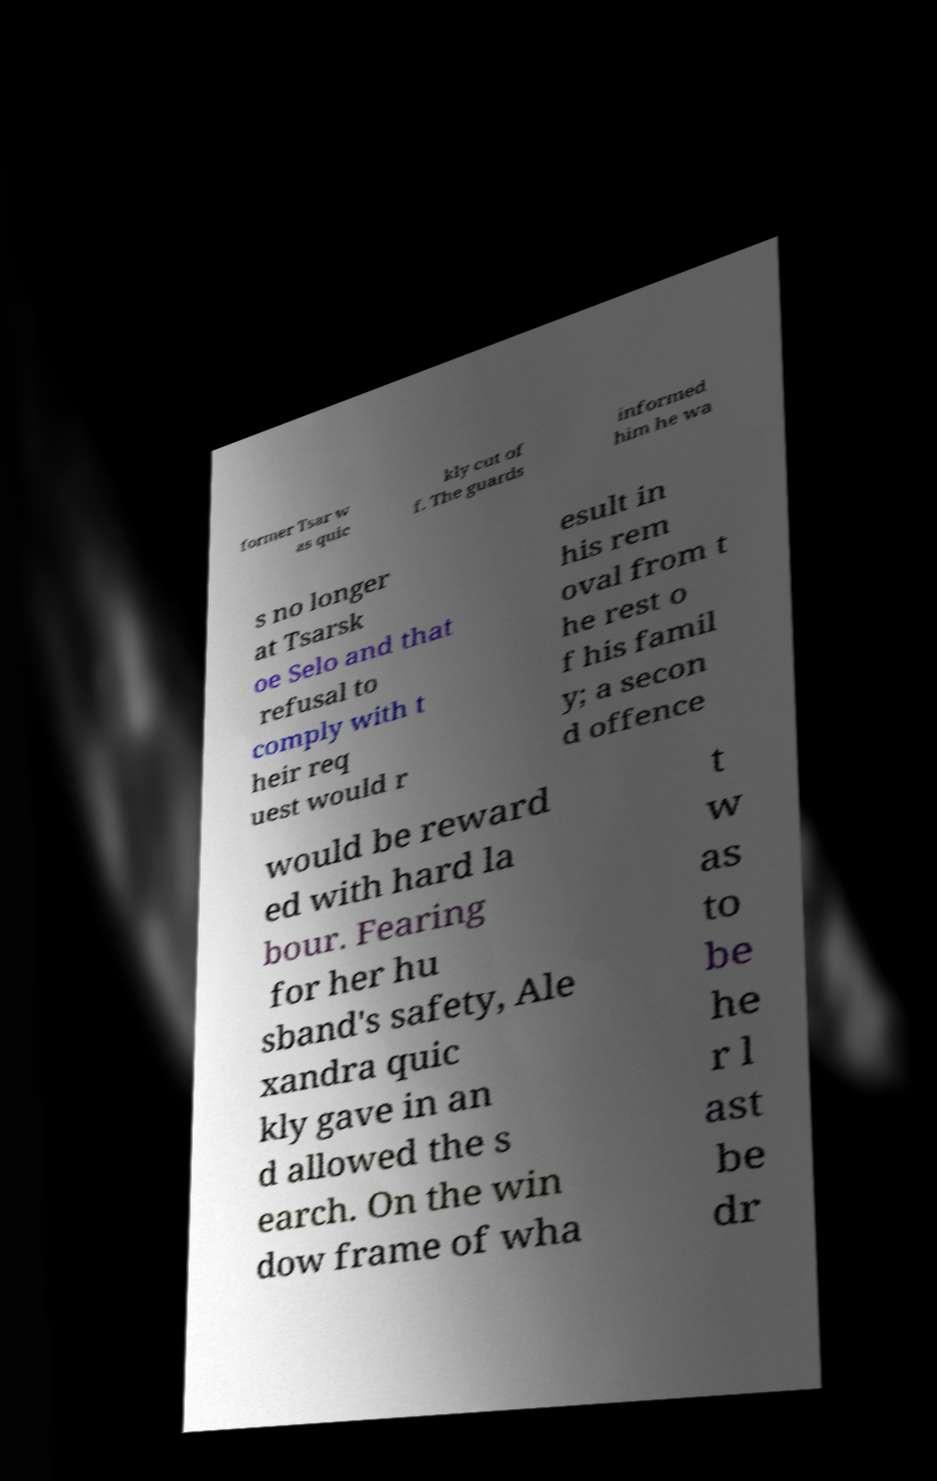Please identify and transcribe the text found in this image. former Tsar w as quic kly cut of f. The guards informed him he wa s no longer at Tsarsk oe Selo and that refusal to comply with t heir req uest would r esult in his rem oval from t he rest o f his famil y; a secon d offence would be reward ed with hard la bour. Fearing for her hu sband's safety, Ale xandra quic kly gave in an d allowed the s earch. On the win dow frame of wha t w as to be he r l ast be dr 